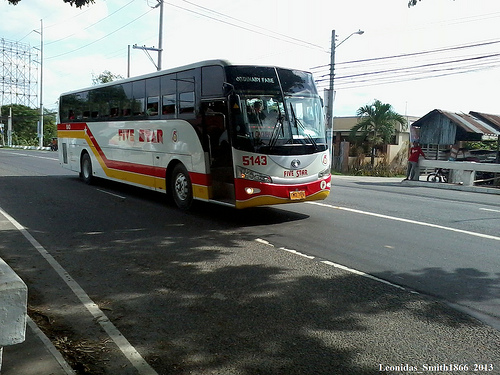How many buses are visible? 1 